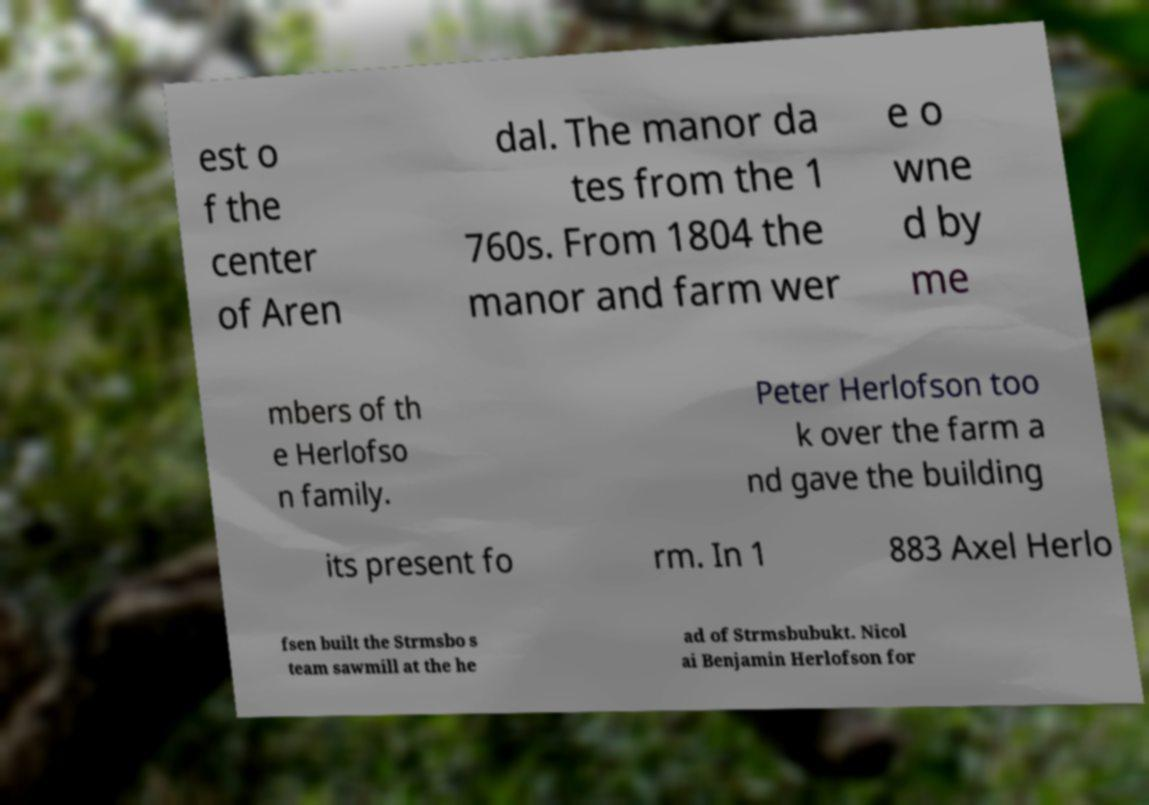There's text embedded in this image that I need extracted. Can you transcribe it verbatim? est o f the center of Aren dal. The manor da tes from the 1 760s. From 1804 the manor and farm wer e o wne d by me mbers of th e Herlofso n family. Peter Herlofson too k over the farm a nd gave the building its present fo rm. In 1 883 Axel Herlo fsen built the Strmsbo s team sawmill at the he ad of Strmsbubukt. Nicol ai Benjamin Herlofson for 